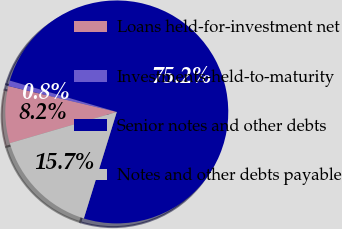<chart> <loc_0><loc_0><loc_500><loc_500><pie_chart><fcel>Loans held-for-investment net<fcel>Investments-held-to-maturity<fcel>Senior notes and other debts<fcel>Notes and other debts payable<nl><fcel>8.25%<fcel>0.81%<fcel>75.24%<fcel>15.7%<nl></chart> 